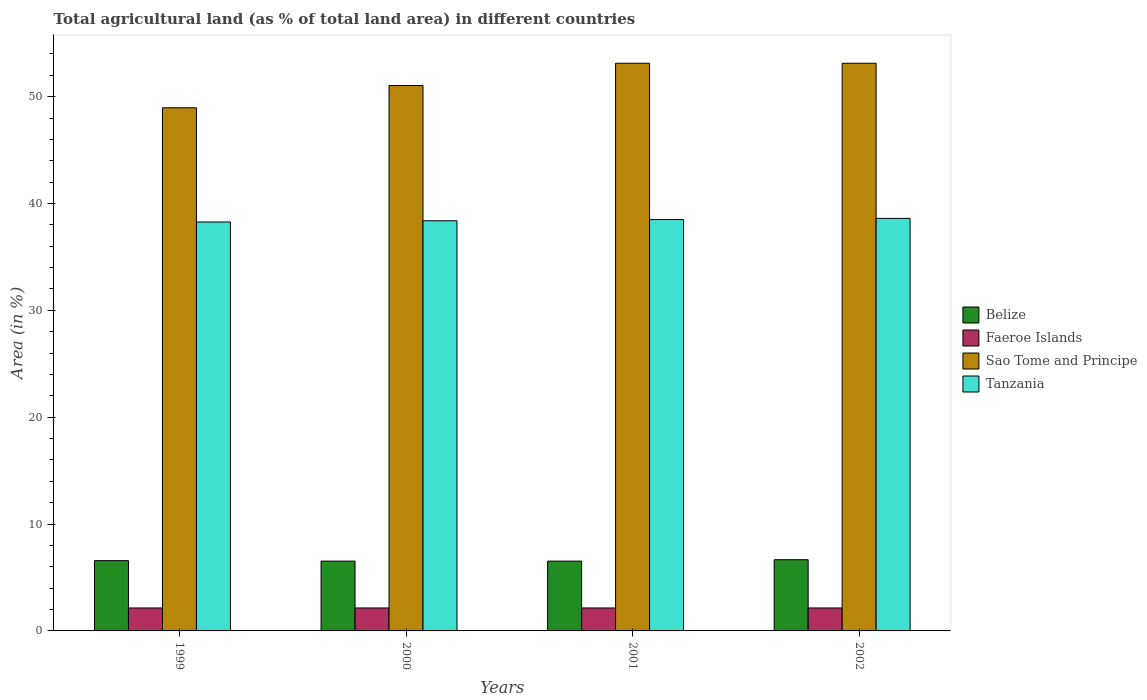How many different coloured bars are there?
Give a very brief answer. 4. How many groups of bars are there?
Offer a terse response. 4. In how many cases, is the number of bars for a given year not equal to the number of legend labels?
Ensure brevity in your answer.  0. What is the percentage of agricultural land in Faeroe Islands in 1999?
Your answer should be compact. 2.15. Across all years, what is the maximum percentage of agricultural land in Belize?
Ensure brevity in your answer.  6.66. Across all years, what is the minimum percentage of agricultural land in Sao Tome and Principe?
Offer a very short reply. 48.96. In which year was the percentage of agricultural land in Sao Tome and Principe minimum?
Provide a short and direct response. 1999. What is the total percentage of agricultural land in Sao Tome and Principe in the graph?
Keep it short and to the point. 206.25. What is the difference between the percentage of agricultural land in Sao Tome and Principe in 1999 and that in 2001?
Make the answer very short. -4.17. What is the difference between the percentage of agricultural land in Sao Tome and Principe in 2001 and the percentage of agricultural land in Tanzania in 2002?
Offer a terse response. 14.52. What is the average percentage of agricultural land in Tanzania per year?
Offer a very short reply. 38.44. In the year 2002, what is the difference between the percentage of agricultural land in Tanzania and percentage of agricultural land in Faeroe Islands?
Your answer should be very brief. 36.46. In how many years, is the percentage of agricultural land in Belize greater than 48 %?
Your answer should be compact. 0. What is the ratio of the percentage of agricultural land in Faeroe Islands in 1999 to that in 2002?
Offer a very short reply. 1. What is the difference between the highest and the lowest percentage of agricultural land in Sao Tome and Principe?
Give a very brief answer. 4.17. In how many years, is the percentage of agricultural land in Belize greater than the average percentage of agricultural land in Belize taken over all years?
Ensure brevity in your answer.  1. Is the sum of the percentage of agricultural land in Faeroe Islands in 1999 and 2001 greater than the maximum percentage of agricultural land in Belize across all years?
Your answer should be very brief. No. Is it the case that in every year, the sum of the percentage of agricultural land in Faeroe Islands and percentage of agricultural land in Tanzania is greater than the sum of percentage of agricultural land in Belize and percentage of agricultural land in Sao Tome and Principe?
Offer a terse response. Yes. What does the 1st bar from the left in 2001 represents?
Your answer should be compact. Belize. What does the 1st bar from the right in 2001 represents?
Keep it short and to the point. Tanzania. Is it the case that in every year, the sum of the percentage of agricultural land in Sao Tome and Principe and percentage of agricultural land in Faeroe Islands is greater than the percentage of agricultural land in Tanzania?
Your answer should be compact. Yes. How many bars are there?
Ensure brevity in your answer.  16. What is the difference between two consecutive major ticks on the Y-axis?
Keep it short and to the point. 10. Are the values on the major ticks of Y-axis written in scientific E-notation?
Provide a succinct answer. No. How are the legend labels stacked?
Make the answer very short. Vertical. What is the title of the graph?
Give a very brief answer. Total agricultural land (as % of total land area) in different countries. What is the label or title of the X-axis?
Give a very brief answer. Years. What is the label or title of the Y-axis?
Offer a very short reply. Area (in %). What is the Area (in %) in Belize in 1999?
Your answer should be very brief. 6.58. What is the Area (in %) of Faeroe Islands in 1999?
Provide a succinct answer. 2.15. What is the Area (in %) of Sao Tome and Principe in 1999?
Give a very brief answer. 48.96. What is the Area (in %) in Tanzania in 1999?
Ensure brevity in your answer.  38.27. What is the Area (in %) of Belize in 2000?
Your answer should be very brief. 6.53. What is the Area (in %) in Faeroe Islands in 2000?
Make the answer very short. 2.15. What is the Area (in %) of Sao Tome and Principe in 2000?
Your answer should be very brief. 51.04. What is the Area (in %) in Tanzania in 2000?
Offer a very short reply. 38.38. What is the Area (in %) in Belize in 2001?
Give a very brief answer. 6.53. What is the Area (in %) of Faeroe Islands in 2001?
Offer a terse response. 2.15. What is the Area (in %) in Sao Tome and Principe in 2001?
Your answer should be compact. 53.12. What is the Area (in %) of Tanzania in 2001?
Your answer should be very brief. 38.5. What is the Area (in %) of Belize in 2002?
Keep it short and to the point. 6.66. What is the Area (in %) in Faeroe Islands in 2002?
Keep it short and to the point. 2.15. What is the Area (in %) in Sao Tome and Principe in 2002?
Offer a very short reply. 53.12. What is the Area (in %) of Tanzania in 2002?
Your answer should be very brief. 38.61. Across all years, what is the maximum Area (in %) in Belize?
Provide a short and direct response. 6.66. Across all years, what is the maximum Area (in %) of Faeroe Islands?
Ensure brevity in your answer.  2.15. Across all years, what is the maximum Area (in %) of Sao Tome and Principe?
Ensure brevity in your answer.  53.12. Across all years, what is the maximum Area (in %) in Tanzania?
Make the answer very short. 38.61. Across all years, what is the minimum Area (in %) in Belize?
Your answer should be very brief. 6.53. Across all years, what is the minimum Area (in %) of Faeroe Islands?
Offer a very short reply. 2.15. Across all years, what is the minimum Area (in %) in Sao Tome and Principe?
Provide a short and direct response. 48.96. Across all years, what is the minimum Area (in %) of Tanzania?
Give a very brief answer. 38.27. What is the total Area (in %) in Belize in the graph?
Your response must be concise. 26.3. What is the total Area (in %) in Faeroe Islands in the graph?
Give a very brief answer. 8.6. What is the total Area (in %) in Sao Tome and Principe in the graph?
Offer a very short reply. 206.25. What is the total Area (in %) of Tanzania in the graph?
Keep it short and to the point. 153.76. What is the difference between the Area (in %) of Belize in 1999 and that in 2000?
Provide a succinct answer. 0.04. What is the difference between the Area (in %) of Faeroe Islands in 1999 and that in 2000?
Provide a short and direct response. 0. What is the difference between the Area (in %) of Sao Tome and Principe in 1999 and that in 2000?
Your response must be concise. -2.08. What is the difference between the Area (in %) of Tanzania in 1999 and that in 2000?
Provide a short and direct response. -0.11. What is the difference between the Area (in %) of Belize in 1999 and that in 2001?
Provide a succinct answer. 0.04. What is the difference between the Area (in %) of Sao Tome and Principe in 1999 and that in 2001?
Your answer should be very brief. -4.17. What is the difference between the Area (in %) of Tanzania in 1999 and that in 2001?
Your answer should be compact. -0.23. What is the difference between the Area (in %) of Belize in 1999 and that in 2002?
Provide a short and direct response. -0.09. What is the difference between the Area (in %) in Sao Tome and Principe in 1999 and that in 2002?
Offer a very short reply. -4.17. What is the difference between the Area (in %) in Tanzania in 1999 and that in 2002?
Your answer should be very brief. -0.34. What is the difference between the Area (in %) in Sao Tome and Principe in 2000 and that in 2001?
Your answer should be compact. -2.08. What is the difference between the Area (in %) of Tanzania in 2000 and that in 2001?
Your answer should be very brief. -0.11. What is the difference between the Area (in %) in Belize in 2000 and that in 2002?
Offer a terse response. -0.13. What is the difference between the Area (in %) of Faeroe Islands in 2000 and that in 2002?
Offer a terse response. 0. What is the difference between the Area (in %) in Sao Tome and Principe in 2000 and that in 2002?
Your answer should be very brief. -2.08. What is the difference between the Area (in %) in Tanzania in 2000 and that in 2002?
Your answer should be very brief. -0.23. What is the difference between the Area (in %) of Belize in 2001 and that in 2002?
Give a very brief answer. -0.13. What is the difference between the Area (in %) in Faeroe Islands in 2001 and that in 2002?
Offer a very short reply. 0. What is the difference between the Area (in %) of Tanzania in 2001 and that in 2002?
Offer a very short reply. -0.11. What is the difference between the Area (in %) in Belize in 1999 and the Area (in %) in Faeroe Islands in 2000?
Provide a short and direct response. 4.43. What is the difference between the Area (in %) of Belize in 1999 and the Area (in %) of Sao Tome and Principe in 2000?
Offer a terse response. -44.47. What is the difference between the Area (in %) in Belize in 1999 and the Area (in %) in Tanzania in 2000?
Provide a succinct answer. -31.81. What is the difference between the Area (in %) of Faeroe Islands in 1999 and the Area (in %) of Sao Tome and Principe in 2000?
Offer a very short reply. -48.89. What is the difference between the Area (in %) of Faeroe Islands in 1999 and the Area (in %) of Tanzania in 2000?
Ensure brevity in your answer.  -36.23. What is the difference between the Area (in %) in Sao Tome and Principe in 1999 and the Area (in %) in Tanzania in 2000?
Your answer should be compact. 10.57. What is the difference between the Area (in %) of Belize in 1999 and the Area (in %) of Faeroe Islands in 2001?
Your answer should be compact. 4.43. What is the difference between the Area (in %) in Belize in 1999 and the Area (in %) in Sao Tome and Principe in 2001?
Offer a very short reply. -46.55. What is the difference between the Area (in %) of Belize in 1999 and the Area (in %) of Tanzania in 2001?
Make the answer very short. -31.92. What is the difference between the Area (in %) of Faeroe Islands in 1999 and the Area (in %) of Sao Tome and Principe in 2001?
Provide a succinct answer. -50.98. What is the difference between the Area (in %) of Faeroe Islands in 1999 and the Area (in %) of Tanzania in 2001?
Give a very brief answer. -36.35. What is the difference between the Area (in %) of Sao Tome and Principe in 1999 and the Area (in %) of Tanzania in 2001?
Offer a very short reply. 10.46. What is the difference between the Area (in %) in Belize in 1999 and the Area (in %) in Faeroe Islands in 2002?
Offer a terse response. 4.43. What is the difference between the Area (in %) in Belize in 1999 and the Area (in %) in Sao Tome and Principe in 2002?
Make the answer very short. -46.55. What is the difference between the Area (in %) in Belize in 1999 and the Area (in %) in Tanzania in 2002?
Your answer should be very brief. -32.03. What is the difference between the Area (in %) in Faeroe Islands in 1999 and the Area (in %) in Sao Tome and Principe in 2002?
Your answer should be very brief. -50.98. What is the difference between the Area (in %) in Faeroe Islands in 1999 and the Area (in %) in Tanzania in 2002?
Provide a short and direct response. -36.46. What is the difference between the Area (in %) of Sao Tome and Principe in 1999 and the Area (in %) of Tanzania in 2002?
Provide a succinct answer. 10.35. What is the difference between the Area (in %) of Belize in 2000 and the Area (in %) of Faeroe Islands in 2001?
Give a very brief answer. 4.38. What is the difference between the Area (in %) in Belize in 2000 and the Area (in %) in Sao Tome and Principe in 2001?
Give a very brief answer. -46.59. What is the difference between the Area (in %) of Belize in 2000 and the Area (in %) of Tanzania in 2001?
Ensure brevity in your answer.  -31.96. What is the difference between the Area (in %) of Faeroe Islands in 2000 and the Area (in %) of Sao Tome and Principe in 2001?
Give a very brief answer. -50.98. What is the difference between the Area (in %) in Faeroe Islands in 2000 and the Area (in %) in Tanzania in 2001?
Your answer should be compact. -36.35. What is the difference between the Area (in %) of Sao Tome and Principe in 2000 and the Area (in %) of Tanzania in 2001?
Keep it short and to the point. 12.55. What is the difference between the Area (in %) in Belize in 2000 and the Area (in %) in Faeroe Islands in 2002?
Provide a short and direct response. 4.38. What is the difference between the Area (in %) of Belize in 2000 and the Area (in %) of Sao Tome and Principe in 2002?
Make the answer very short. -46.59. What is the difference between the Area (in %) in Belize in 2000 and the Area (in %) in Tanzania in 2002?
Ensure brevity in your answer.  -32.08. What is the difference between the Area (in %) in Faeroe Islands in 2000 and the Area (in %) in Sao Tome and Principe in 2002?
Your answer should be compact. -50.98. What is the difference between the Area (in %) of Faeroe Islands in 2000 and the Area (in %) of Tanzania in 2002?
Ensure brevity in your answer.  -36.46. What is the difference between the Area (in %) in Sao Tome and Principe in 2000 and the Area (in %) in Tanzania in 2002?
Offer a very short reply. 12.43. What is the difference between the Area (in %) of Belize in 2001 and the Area (in %) of Faeroe Islands in 2002?
Provide a short and direct response. 4.38. What is the difference between the Area (in %) in Belize in 2001 and the Area (in %) in Sao Tome and Principe in 2002?
Give a very brief answer. -46.59. What is the difference between the Area (in %) in Belize in 2001 and the Area (in %) in Tanzania in 2002?
Keep it short and to the point. -32.08. What is the difference between the Area (in %) in Faeroe Islands in 2001 and the Area (in %) in Sao Tome and Principe in 2002?
Offer a very short reply. -50.98. What is the difference between the Area (in %) in Faeroe Islands in 2001 and the Area (in %) in Tanzania in 2002?
Offer a terse response. -36.46. What is the difference between the Area (in %) in Sao Tome and Principe in 2001 and the Area (in %) in Tanzania in 2002?
Make the answer very short. 14.52. What is the average Area (in %) of Belize per year?
Your answer should be very brief. 6.58. What is the average Area (in %) in Faeroe Islands per year?
Your response must be concise. 2.15. What is the average Area (in %) in Sao Tome and Principe per year?
Make the answer very short. 51.56. What is the average Area (in %) of Tanzania per year?
Offer a very short reply. 38.44. In the year 1999, what is the difference between the Area (in %) in Belize and Area (in %) in Faeroe Islands?
Your response must be concise. 4.43. In the year 1999, what is the difference between the Area (in %) in Belize and Area (in %) in Sao Tome and Principe?
Give a very brief answer. -42.38. In the year 1999, what is the difference between the Area (in %) in Belize and Area (in %) in Tanzania?
Provide a succinct answer. -31.69. In the year 1999, what is the difference between the Area (in %) of Faeroe Islands and Area (in %) of Sao Tome and Principe?
Give a very brief answer. -46.81. In the year 1999, what is the difference between the Area (in %) of Faeroe Islands and Area (in %) of Tanzania?
Your response must be concise. -36.12. In the year 1999, what is the difference between the Area (in %) of Sao Tome and Principe and Area (in %) of Tanzania?
Make the answer very short. 10.69. In the year 2000, what is the difference between the Area (in %) in Belize and Area (in %) in Faeroe Islands?
Offer a terse response. 4.38. In the year 2000, what is the difference between the Area (in %) of Belize and Area (in %) of Sao Tome and Principe?
Keep it short and to the point. -44.51. In the year 2000, what is the difference between the Area (in %) of Belize and Area (in %) of Tanzania?
Provide a short and direct response. -31.85. In the year 2000, what is the difference between the Area (in %) of Faeroe Islands and Area (in %) of Sao Tome and Principe?
Give a very brief answer. -48.89. In the year 2000, what is the difference between the Area (in %) in Faeroe Islands and Area (in %) in Tanzania?
Make the answer very short. -36.23. In the year 2000, what is the difference between the Area (in %) in Sao Tome and Principe and Area (in %) in Tanzania?
Provide a succinct answer. 12.66. In the year 2001, what is the difference between the Area (in %) in Belize and Area (in %) in Faeroe Islands?
Offer a very short reply. 4.38. In the year 2001, what is the difference between the Area (in %) of Belize and Area (in %) of Sao Tome and Principe?
Give a very brief answer. -46.59. In the year 2001, what is the difference between the Area (in %) in Belize and Area (in %) in Tanzania?
Give a very brief answer. -31.96. In the year 2001, what is the difference between the Area (in %) in Faeroe Islands and Area (in %) in Sao Tome and Principe?
Your answer should be very brief. -50.98. In the year 2001, what is the difference between the Area (in %) in Faeroe Islands and Area (in %) in Tanzania?
Offer a terse response. -36.35. In the year 2001, what is the difference between the Area (in %) in Sao Tome and Principe and Area (in %) in Tanzania?
Give a very brief answer. 14.63. In the year 2002, what is the difference between the Area (in %) of Belize and Area (in %) of Faeroe Islands?
Your answer should be compact. 4.51. In the year 2002, what is the difference between the Area (in %) in Belize and Area (in %) in Sao Tome and Principe?
Your answer should be compact. -46.46. In the year 2002, what is the difference between the Area (in %) of Belize and Area (in %) of Tanzania?
Offer a terse response. -31.95. In the year 2002, what is the difference between the Area (in %) in Faeroe Islands and Area (in %) in Sao Tome and Principe?
Ensure brevity in your answer.  -50.98. In the year 2002, what is the difference between the Area (in %) in Faeroe Islands and Area (in %) in Tanzania?
Offer a terse response. -36.46. In the year 2002, what is the difference between the Area (in %) of Sao Tome and Principe and Area (in %) of Tanzania?
Offer a terse response. 14.52. What is the ratio of the Area (in %) in Sao Tome and Principe in 1999 to that in 2000?
Ensure brevity in your answer.  0.96. What is the ratio of the Area (in %) of Faeroe Islands in 1999 to that in 2001?
Your answer should be compact. 1. What is the ratio of the Area (in %) of Sao Tome and Principe in 1999 to that in 2001?
Your answer should be very brief. 0.92. What is the ratio of the Area (in %) in Faeroe Islands in 1999 to that in 2002?
Your answer should be very brief. 1. What is the ratio of the Area (in %) in Sao Tome and Principe in 1999 to that in 2002?
Ensure brevity in your answer.  0.92. What is the ratio of the Area (in %) in Faeroe Islands in 2000 to that in 2001?
Your answer should be compact. 1. What is the ratio of the Area (in %) in Sao Tome and Principe in 2000 to that in 2001?
Provide a succinct answer. 0.96. What is the ratio of the Area (in %) of Belize in 2000 to that in 2002?
Make the answer very short. 0.98. What is the ratio of the Area (in %) of Sao Tome and Principe in 2000 to that in 2002?
Your answer should be very brief. 0.96. What is the ratio of the Area (in %) in Belize in 2001 to that in 2002?
Make the answer very short. 0.98. What is the difference between the highest and the second highest Area (in %) of Belize?
Keep it short and to the point. 0.09. What is the difference between the highest and the second highest Area (in %) in Faeroe Islands?
Offer a terse response. 0. What is the difference between the highest and the second highest Area (in %) in Sao Tome and Principe?
Offer a very short reply. 0. What is the difference between the highest and the second highest Area (in %) in Tanzania?
Your answer should be compact. 0.11. What is the difference between the highest and the lowest Area (in %) of Belize?
Your answer should be compact. 0.13. What is the difference between the highest and the lowest Area (in %) in Faeroe Islands?
Your answer should be very brief. 0. What is the difference between the highest and the lowest Area (in %) of Sao Tome and Principe?
Offer a terse response. 4.17. What is the difference between the highest and the lowest Area (in %) of Tanzania?
Provide a short and direct response. 0.34. 